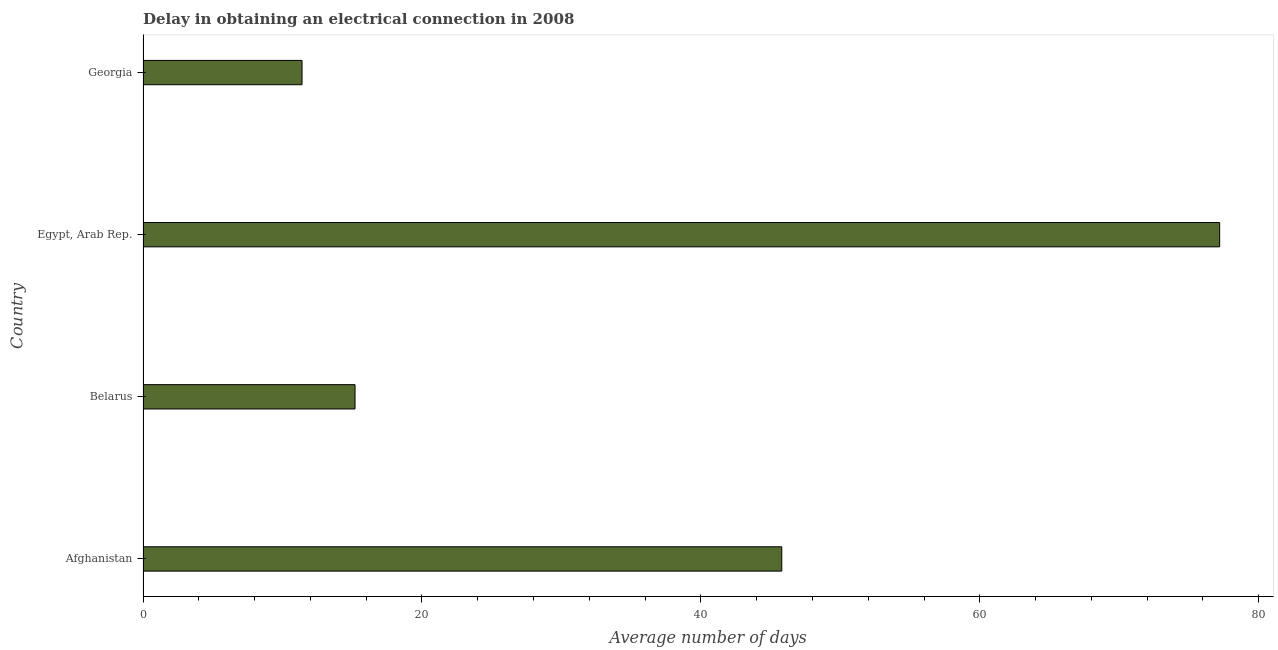What is the title of the graph?
Give a very brief answer. Delay in obtaining an electrical connection in 2008. What is the label or title of the X-axis?
Your answer should be compact. Average number of days. What is the label or title of the Y-axis?
Offer a very short reply. Country. What is the dalay in electrical connection in Belarus?
Offer a terse response. 15.2. Across all countries, what is the maximum dalay in electrical connection?
Keep it short and to the point. 77.2. Across all countries, what is the minimum dalay in electrical connection?
Offer a terse response. 11.4. In which country was the dalay in electrical connection maximum?
Give a very brief answer. Egypt, Arab Rep. In which country was the dalay in electrical connection minimum?
Provide a short and direct response. Georgia. What is the sum of the dalay in electrical connection?
Provide a succinct answer. 149.6. What is the difference between the dalay in electrical connection in Afghanistan and Egypt, Arab Rep.?
Your answer should be very brief. -31.4. What is the average dalay in electrical connection per country?
Provide a short and direct response. 37.4. What is the median dalay in electrical connection?
Ensure brevity in your answer.  30.5. What is the ratio of the dalay in electrical connection in Egypt, Arab Rep. to that in Georgia?
Your answer should be compact. 6.77. What is the difference between the highest and the second highest dalay in electrical connection?
Your answer should be compact. 31.4. What is the difference between the highest and the lowest dalay in electrical connection?
Keep it short and to the point. 65.8. In how many countries, is the dalay in electrical connection greater than the average dalay in electrical connection taken over all countries?
Make the answer very short. 2. Are all the bars in the graph horizontal?
Ensure brevity in your answer.  Yes. What is the difference between two consecutive major ticks on the X-axis?
Make the answer very short. 20. What is the Average number of days of Afghanistan?
Offer a very short reply. 45.8. What is the Average number of days in Belarus?
Offer a terse response. 15.2. What is the Average number of days in Egypt, Arab Rep.?
Ensure brevity in your answer.  77.2. What is the Average number of days of Georgia?
Your answer should be very brief. 11.4. What is the difference between the Average number of days in Afghanistan and Belarus?
Keep it short and to the point. 30.6. What is the difference between the Average number of days in Afghanistan and Egypt, Arab Rep.?
Your answer should be very brief. -31.4. What is the difference between the Average number of days in Afghanistan and Georgia?
Make the answer very short. 34.4. What is the difference between the Average number of days in Belarus and Egypt, Arab Rep.?
Offer a very short reply. -62. What is the difference between the Average number of days in Belarus and Georgia?
Your answer should be very brief. 3.8. What is the difference between the Average number of days in Egypt, Arab Rep. and Georgia?
Offer a terse response. 65.8. What is the ratio of the Average number of days in Afghanistan to that in Belarus?
Offer a very short reply. 3.01. What is the ratio of the Average number of days in Afghanistan to that in Egypt, Arab Rep.?
Your answer should be compact. 0.59. What is the ratio of the Average number of days in Afghanistan to that in Georgia?
Keep it short and to the point. 4.02. What is the ratio of the Average number of days in Belarus to that in Egypt, Arab Rep.?
Offer a terse response. 0.2. What is the ratio of the Average number of days in Belarus to that in Georgia?
Offer a very short reply. 1.33. What is the ratio of the Average number of days in Egypt, Arab Rep. to that in Georgia?
Ensure brevity in your answer.  6.77. 